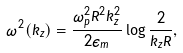<formula> <loc_0><loc_0><loc_500><loc_500>\omega ^ { 2 } ( k _ { z } ) = \frac { \omega _ { p } ^ { 2 } R ^ { 2 } k _ { z } ^ { 2 } } { 2 \epsilon _ { m } } \log { \frac { 2 } { k _ { z } R } } ,</formula> 